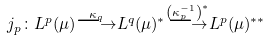Convert formula to latex. <formula><loc_0><loc_0><loc_500><loc_500>j _ { p } \colon L ^ { p } ( \mu ) { \overset { \kappa _ { q } } { \longrightarrow } } L ^ { q } ( \mu ) ^ { * } { \overset { \left ( \kappa _ { p } ^ { - 1 } \right ) ^ { * } } { \longrightarrow } } L ^ { p } ( \mu ) ^ { * * }</formula> 